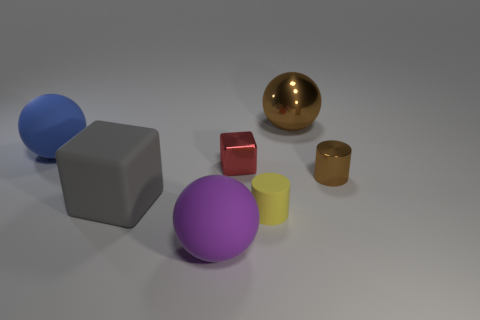Are there fewer blocks than small yellow shiny blocks?
Ensure brevity in your answer.  No. There is a yellow object that is the same size as the red shiny object; what is its material?
Keep it short and to the point. Rubber. Does the rubber object to the right of the purple object have the same size as the rubber ball in front of the large blue rubber thing?
Keep it short and to the point. No. Are there any large red blocks made of the same material as the blue ball?
Make the answer very short. No. How many things are either brown things right of the metallic ball or gray objects?
Provide a succinct answer. 2. Is the material of the blue thing behind the tiny yellow rubber thing the same as the tiny cube?
Your response must be concise. No. Does the tiny matte thing have the same shape as the small red metallic object?
Provide a short and direct response. No. There is a brown thing that is in front of the big brown thing; how many big blue rubber things are on the left side of it?
Keep it short and to the point. 1. What material is the small yellow object that is the same shape as the small brown thing?
Make the answer very short. Rubber. There is a small thing left of the tiny yellow object; is it the same color as the metallic cylinder?
Make the answer very short. No. 